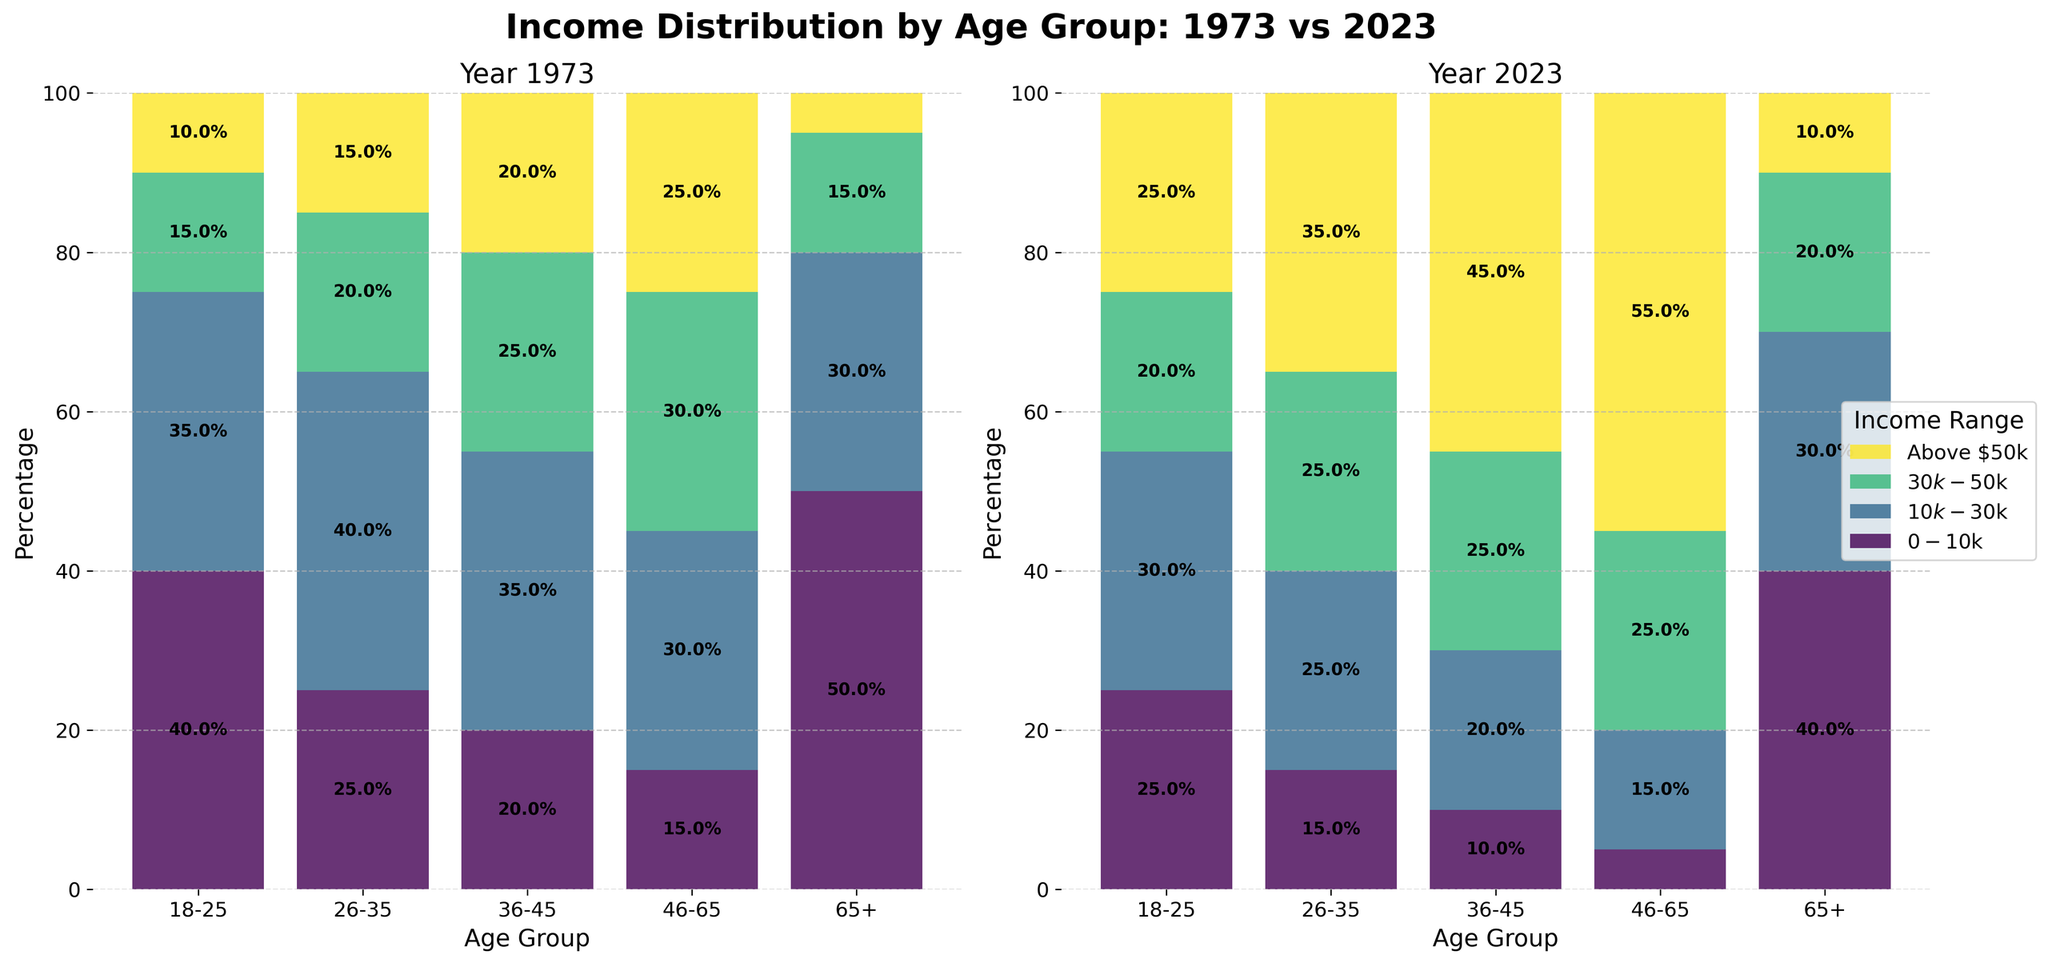What's the percentage of individuals aged 18-25 earning above $50k in 1973? According to the 1973 subplot, find the Age Group '18-25' and look at the segment marked 'Above $50k'. The percentage label inside this segment shows the value.
Answer: 10% How has the percentage of individuals aged 46-65 earning $30k-$50k changed from 1973 to 2023? Compare the segments labelled '$30k-$50k' for the Age Group '46-65' in both the 1973 and 2023 subplots. The percentage for 1973 is 30% and for 2023 it remains 25%.
Answer: Decreased by 5% Which age group saw the most significant increase in the percentage of individuals earning above $50k from 1973 to 2023? Look at the 'Above $50k' segments for all age groups across both subplots and calculate the differences. The 46-65 age group went from 25% to 55%, an increase of 30%.
Answer: 46-65 In 2023, which age group has the highest percentage of individuals earning $10k-$30k? According to the 2023 subplot, compare the '$10k-$30k' segments for all age groups. The age group '65+' has the highest percentage at 30%.
Answer: 65+ What is the combined percentage of individuals aged 26-35 earning between $10k-$50k in 1973? Sum the percentages of the segments '$10k-$30k' (40%) and '$30k-$50k' (20%) for Age Group '26-35' in the 1973 subplot.
Answer: 60% How did the percentage distribution for the age group 65+ change from 1973 to 2023 for income below $10k? Compare the '$0-$10k' segment for the Age Group '65+' in both subplots. The percentage for 1973 was 50%, and for 2023 it is 40%.
Answer: Decreased by 10% Which income range became less significant for individuals aged 36-45 from 1973 to 2023? Compare all income ranges for the Age Group '36-45' across both years. The '$10k-$30k' range decreased from 35% to 20%.
Answer: $10k-$30k What's the total percentage of individuals aged 18-25 earning less than $30k in 2023? Sum the percentages of the segments '$0-$10k' (25%) and '$10k-$30k' (30%) for Age Group '18-25' in the 2023 subplot.
Answer: 55% What is the trend observed in the percentage of individuals aged 65+ earning above $50k from 1973 to 2023? Observe the 'Above $50k' segments for Age Group '65+' in both subplots. There is an increase from 5% in 1973 to 10% in 2023.
Answer: Increased How did the percentage of individuals aged 26-35 earning $0-$10k change from 1973 to 2023? Compare the '$0-$10k' segments for the Age Group '26-35' across both years. The percentage changed from 25% in 1973 to 15% in 2023.
Answer: Decreased by 10% 